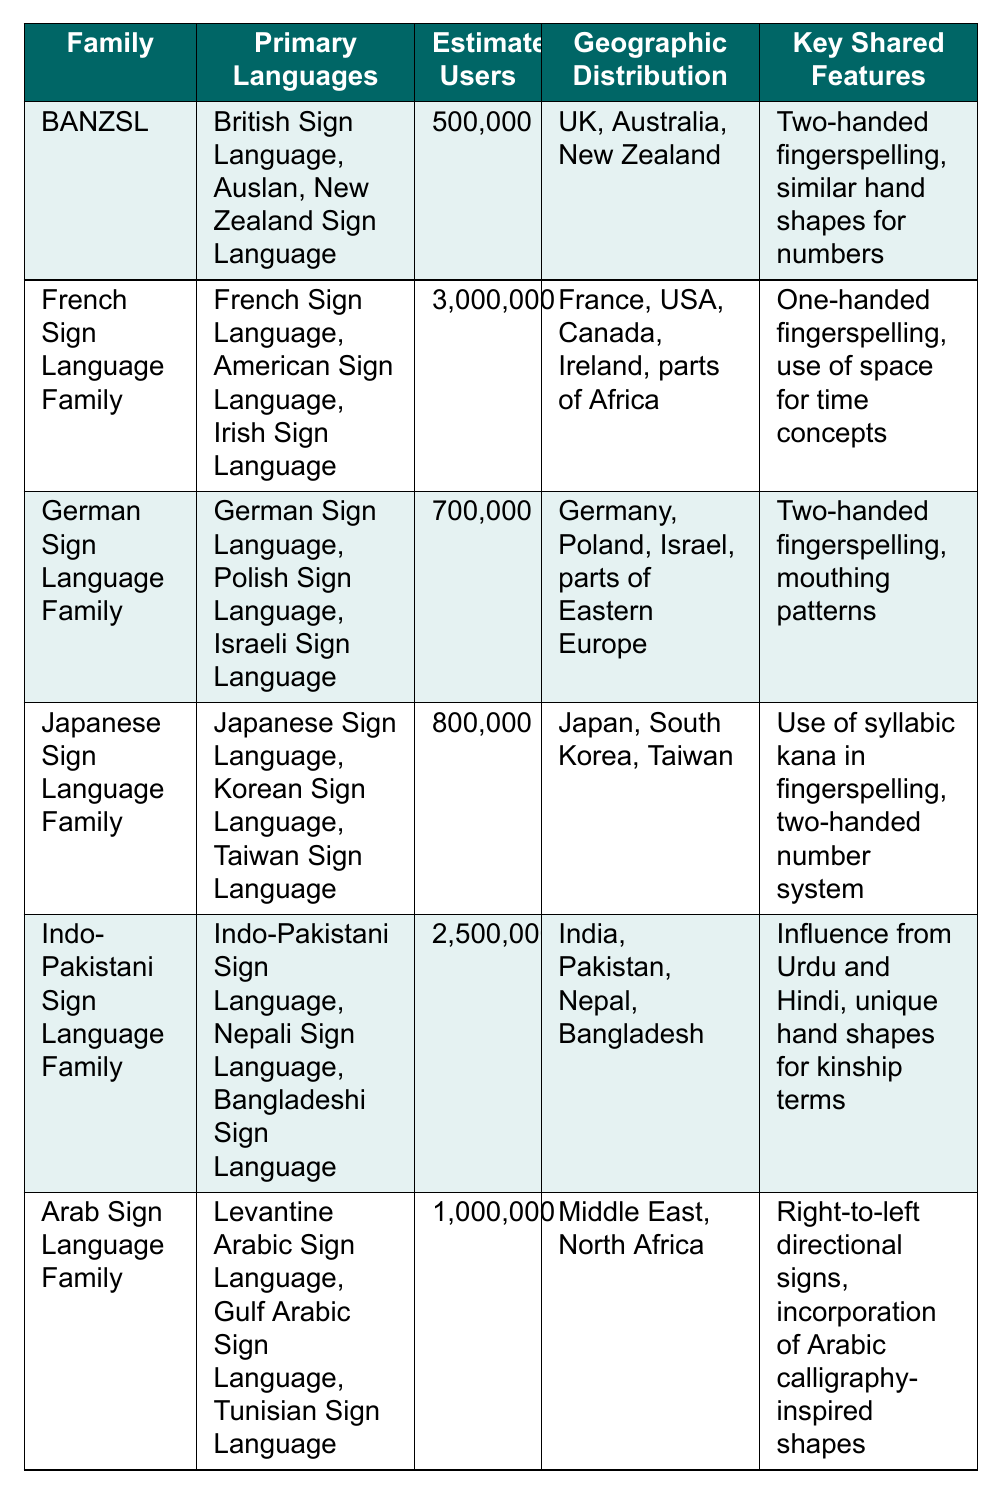What is the estimated number of users for the French Sign Language Family? The table indicates that the estimated number of users for the French Sign Language Family is 3,000,000.
Answer: 3,000,000 Which sign language family has the highest number of estimated users? By comparing the estimated users in the table, the French Sign Language Family has the highest number at 3,000,000.
Answer: French Sign Language Family What geographic regions are associated with the BANZSL family? The table shows that BANZSL is distributed in the UK, Australia, and New Zealand.
Answer: UK, Australia, New Zealand True or False: The Indo-Pakistani Sign Language Family includes sign languages from India, Nepal, and Bangladesh. The table lists the Indo-Pakistani Sign Language Family with primary languages from India, Pakistan, Nepal, and Bangladesh, confirming this is true.
Answer: True How many primary languages are listed under the Arab Sign Language Family? The table lists three primary languages under the Arab Sign Language Family: Levantine Arabic Sign Language, Gulf Arabic Sign Language, and Tunisian Sign Language.
Answer: 3 What are the key shared features of the German Sign Language Family? According to the table, the key shared features of the German Sign Language Family are two-handed fingerspelling and mouthing patterns.
Answer: Two-handed fingerspelling, mouthing patterns If you combine the estimated users of the Japanese and German Sign Language Families, how many users would that total? The table states that the Japanese Sign Language Family has 800,000 users and the German Sign Language Family has 700,000 users. Adding them together gives 800,000 + 700,000 = 1,500,000.
Answer: 1,500,000 Which sign language family is reported to include languages influenced by Urdu and Hindi? The table states that the Indo-Pakistani Sign Language Family has languages influenced by Urdu and Hindi.
Answer: Indo-Pakistani Sign Language Family What is the key shared feature that distinguishes the French Sign Language Family from others? The table notes that the French Sign Language Family is characterized by one-handed fingerspelling and the use of space for time concepts, which distinguish it from other families.
Answer: One-handed fingerspelling, use of space for time concepts How many language families have two-handed fingerspelling as a shared feature? The table shows that both the BANZSL and German Sign Language Families have two-handed fingerspelling as shared features. Thus, there are two families with that feature.
Answer: 2 